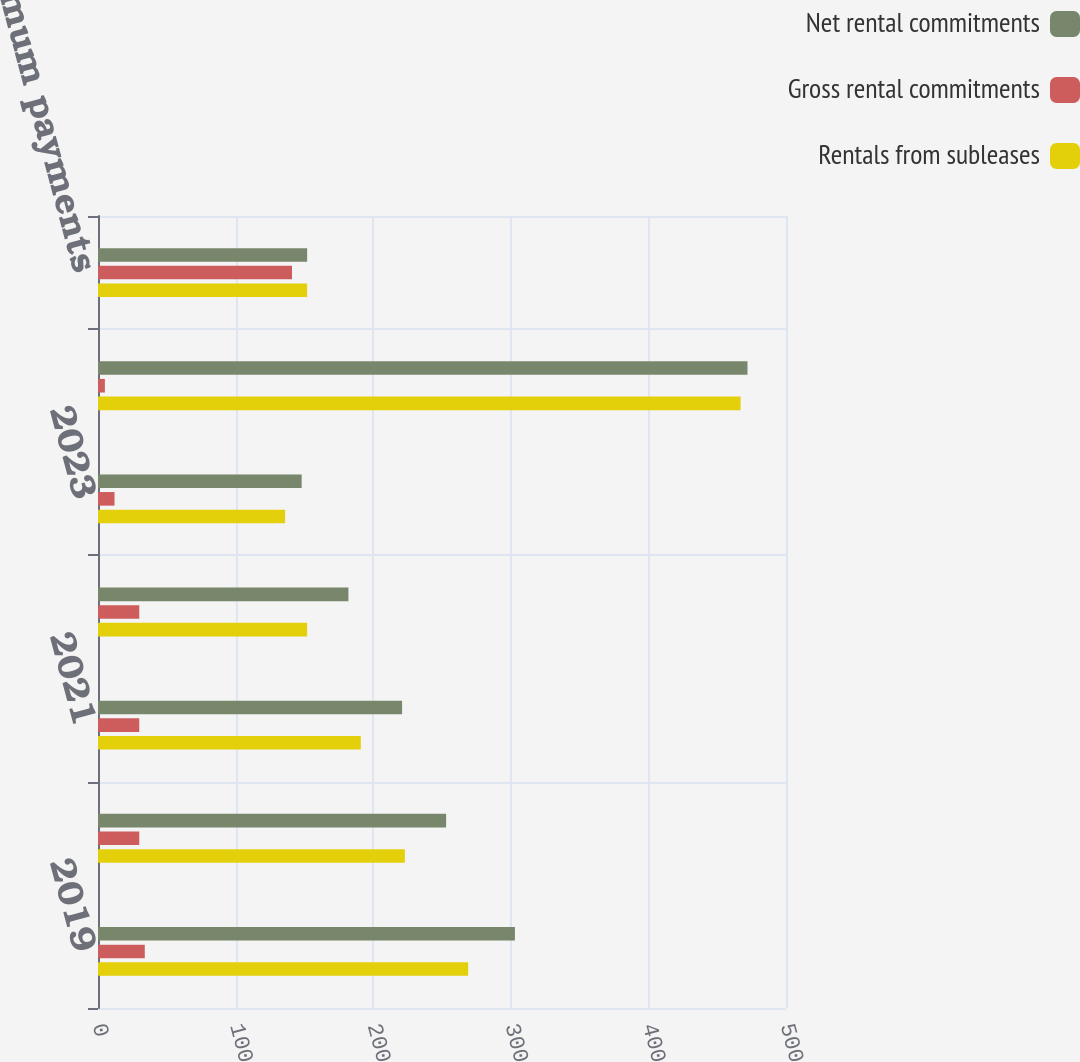Convert chart. <chart><loc_0><loc_0><loc_500><loc_500><stacked_bar_chart><ecel><fcel>2019<fcel>2020<fcel>2021<fcel>2022<fcel>2023<fcel>Thereafter<fcel>Total minimum payments<nl><fcel>Net rental commitments<fcel>303<fcel>253<fcel>221<fcel>182<fcel>148<fcel>472<fcel>152<nl><fcel>Gross rental commitments<fcel>34<fcel>30<fcel>30<fcel>30<fcel>12<fcel>5<fcel>141<nl><fcel>Rentals from subleases<fcel>269<fcel>223<fcel>191<fcel>152<fcel>136<fcel>467<fcel>152<nl></chart> 